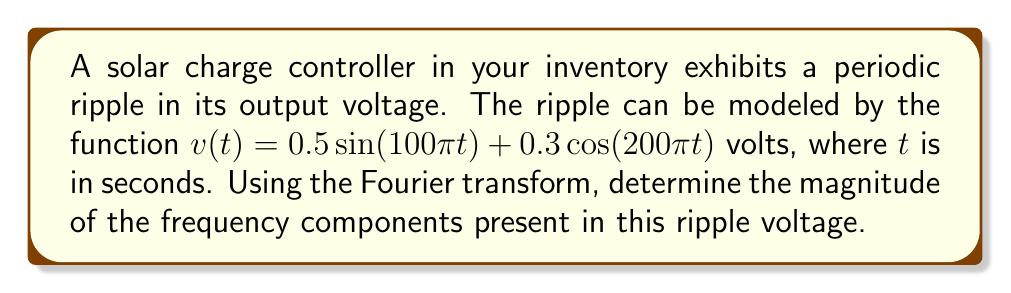Show me your answer to this math problem. To solve this problem, we need to apply the Fourier transform to the given function and analyze its frequency components. Let's break it down step-by-step:

1) The Fourier transform of a sinusoidal function is given by:
   $$\mathcal{F}\{A\sin(\omega t)\} = \frac{Ai}{2}[\delta(\omega + \omega_0) - \delta(\omega - \omega_0)]$$
   $$\mathcal{F}\{A\cos(\omega t)\} = \frac{A}{2}[\delta(\omega + \omega_0) + \delta(\omega - \omega_0)]$$

2) For our function $v(t) = 0.5\sin(100\pi t) + 0.3\cos(200\pi t)$, we have two terms:
   - Term 1: $0.5\sin(100\pi t)$ where $A_1 = 0.5$ and $\omega_1 = 100\pi$
   - Term 2: $0.3\cos(200\pi t)$ where $A_2 = 0.3$ and $\omega_2 = 200\pi$

3) Applying the Fourier transform to each term:
   - For Term 1: $$\mathcal{F}\{0.5\sin(100\pi t)\} = \frac{0.5i}{2}[\delta(\omega + 100\pi) - \delta(\omega - 100\pi)]$$
   - For Term 2: $$\mathcal{F}\{0.3\cos(200\pi t)\} = \frac{0.3}{2}[\delta(\omega + 200\pi) + \delta(\omega - 200\pi)]$$

4) The complete Fourier transform is the sum of these two terms:
   $$V(\omega) = \frac{0.5i}{2}[\delta(\omega + 100\pi) - \delta(\omega - 100\pi)] + \frac{0.3}{2}[\delta(\omega + 200\pi) + \delta(\omega - 200\pi)]$$

5) To find the magnitude of the frequency components, we need to evaluate $|V(\omega)|$ at the non-zero frequencies:
   - At $\omega = \pm 100\pi$: $|V(\pm 100\pi)| = |\frac{0.5i}{2}| = 0.25$
   - At $\omega = \pm 200\pi$: $|V(\pm 200\pi)| = |\frac{0.3}{2}| = 0.15$

Therefore, there are two frequency components in the ripple voltage:
- A component at 50 Hz (corresponding to $\omega = 100\pi$) with magnitude 0.25 V
- A component at 100 Hz (corresponding to $\omega = 200\pi$) with magnitude 0.15 V
Answer: The ripple voltage has two frequency components:
1) 50 Hz component with magnitude 0.25 V
2) 100 Hz component with magnitude 0.15 V 